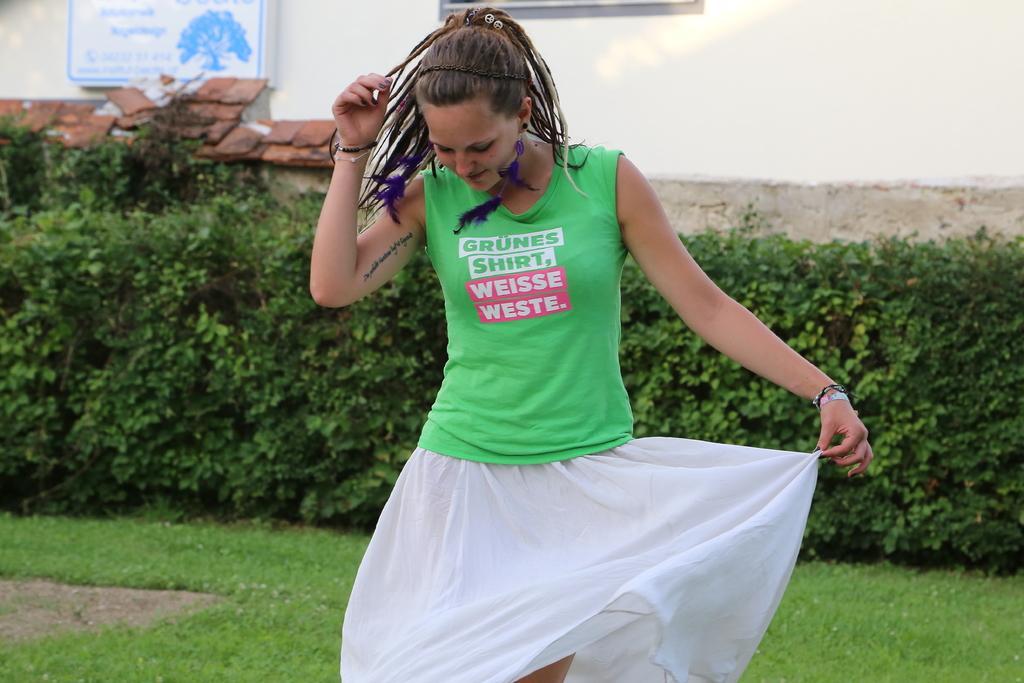Could you give a brief overview of what you see in this image? In this image a woman wearing green t-shirt and white skirt is standing in front of a building. In the background there are plants, building. Here there is a board. 